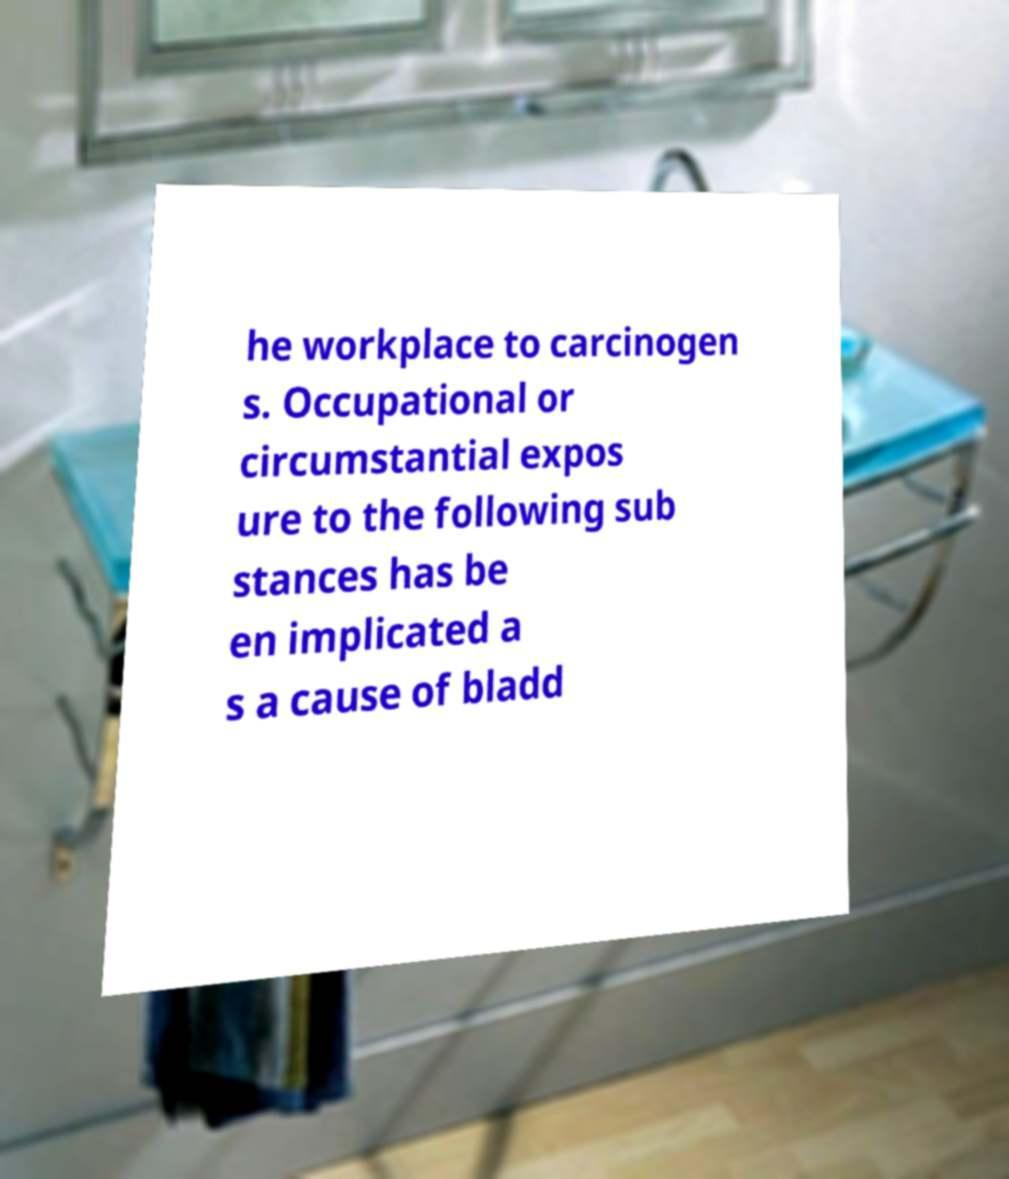Could you assist in decoding the text presented in this image and type it out clearly? he workplace to carcinogen s. Occupational or circumstantial expos ure to the following sub stances has be en implicated a s a cause of bladd 